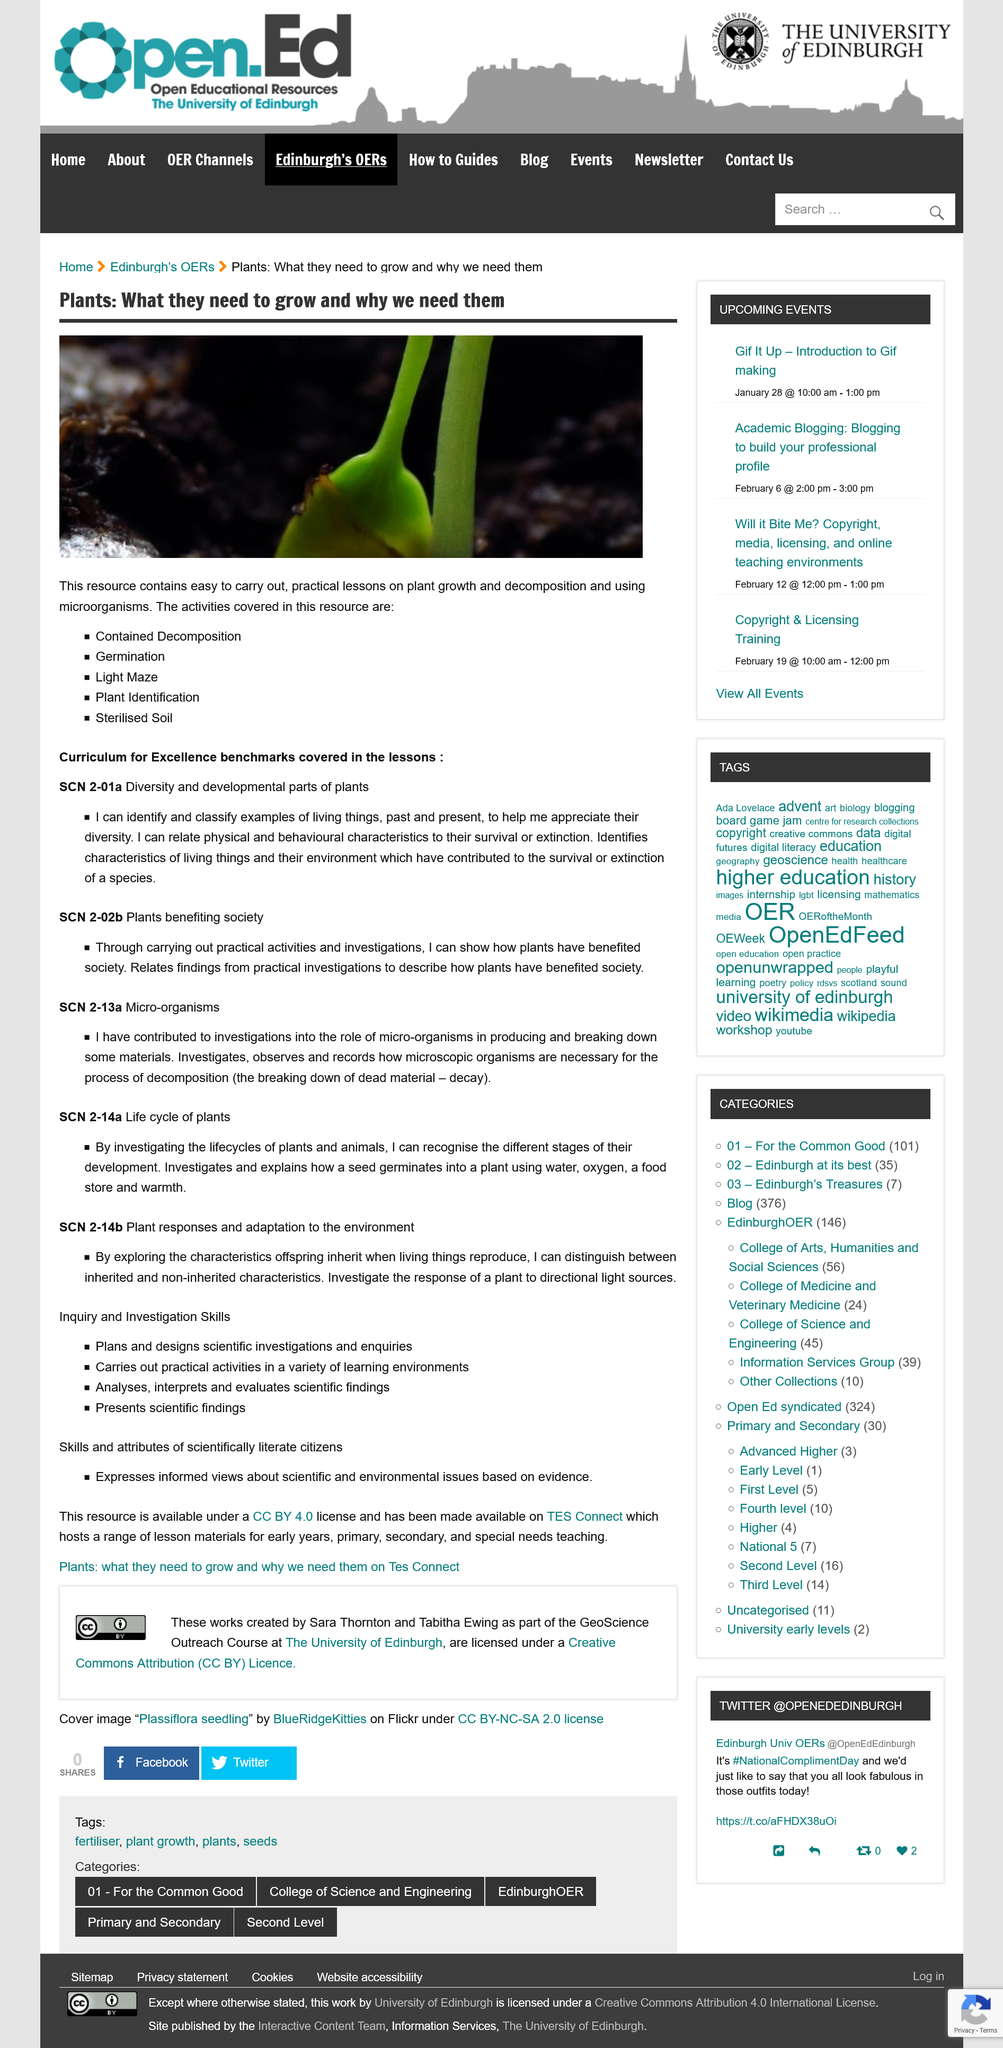Point out several critical features in this image. The SCN 2-13a relates to the exploration of how organisms contribute to the formation and decomposition of certain substances in the natural environment. Five activities are covered in this resource. In this context, decomposition refers to the breaking down of dead material into smaller components. The text states that the study presents scientific findings. This concerns plant responses and adaptations in response to their environment. 